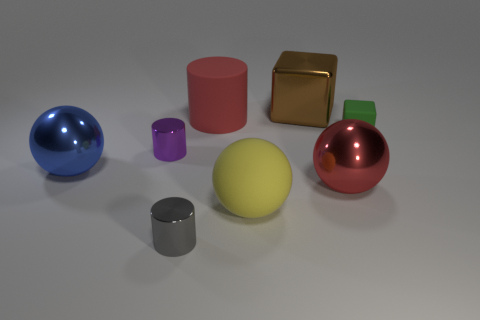Subtract all yellow spheres. How many spheres are left? 2 Subtract 2 cubes. How many cubes are left? 0 Add 1 large cyan cubes. How many objects exist? 9 Subtract all red cylinders. How many cylinders are left? 2 Subtract all cylinders. How many objects are left? 5 Subtract all small purple objects. Subtract all yellow rubber spheres. How many objects are left? 6 Add 1 blue shiny objects. How many blue shiny objects are left? 2 Add 8 yellow rubber things. How many yellow rubber things exist? 9 Subtract 1 blue balls. How many objects are left? 7 Subtract all blue cylinders. Subtract all red blocks. How many cylinders are left? 3 